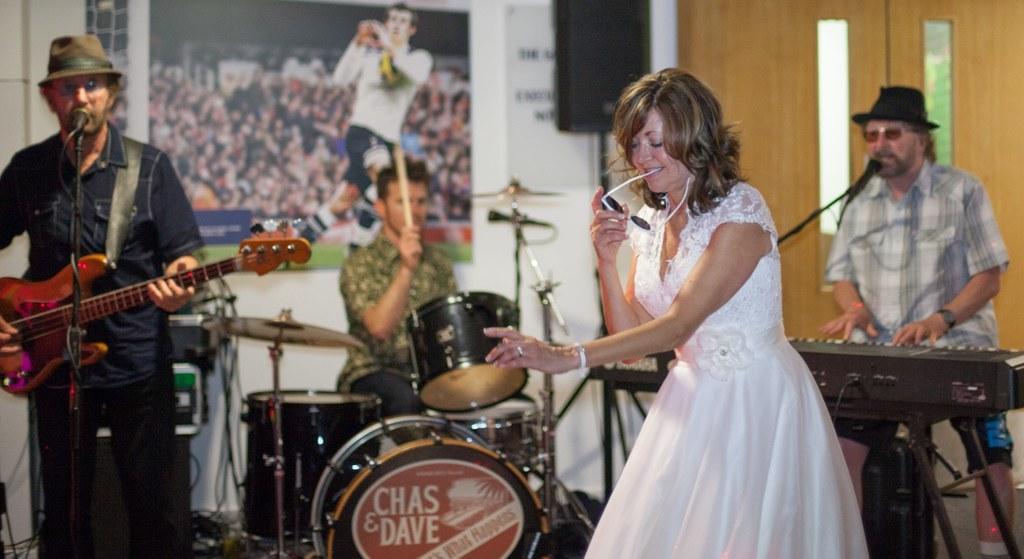Describe this image in one or two sentences. It is an event a women wearing white frock is dancing around her there are total three people one person is playing piano to his left other person is playing drums beside him a person is standing and playing the guitar,in the background to the wall there is a poster to the right side there is a speaker beside the speaker there is a door. 